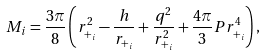Convert formula to latex. <formula><loc_0><loc_0><loc_500><loc_500>M _ { i } = \frac { 3 \pi } { 8 } \left ( r _ { + _ { i } } ^ { 2 } - \frac { h } { r _ { + _ { i } } } + \frac { q ^ { 2 } } { r _ { + _ { i } } ^ { 2 } } + \frac { 4 \pi } { 3 } P r _ { + _ { i } } ^ { 4 } \right ) ,</formula> 